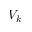Convert formula to latex. <formula><loc_0><loc_0><loc_500><loc_500>V _ { k }</formula> 